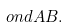<formula> <loc_0><loc_0><loc_500><loc_500>o n d A B .</formula> 